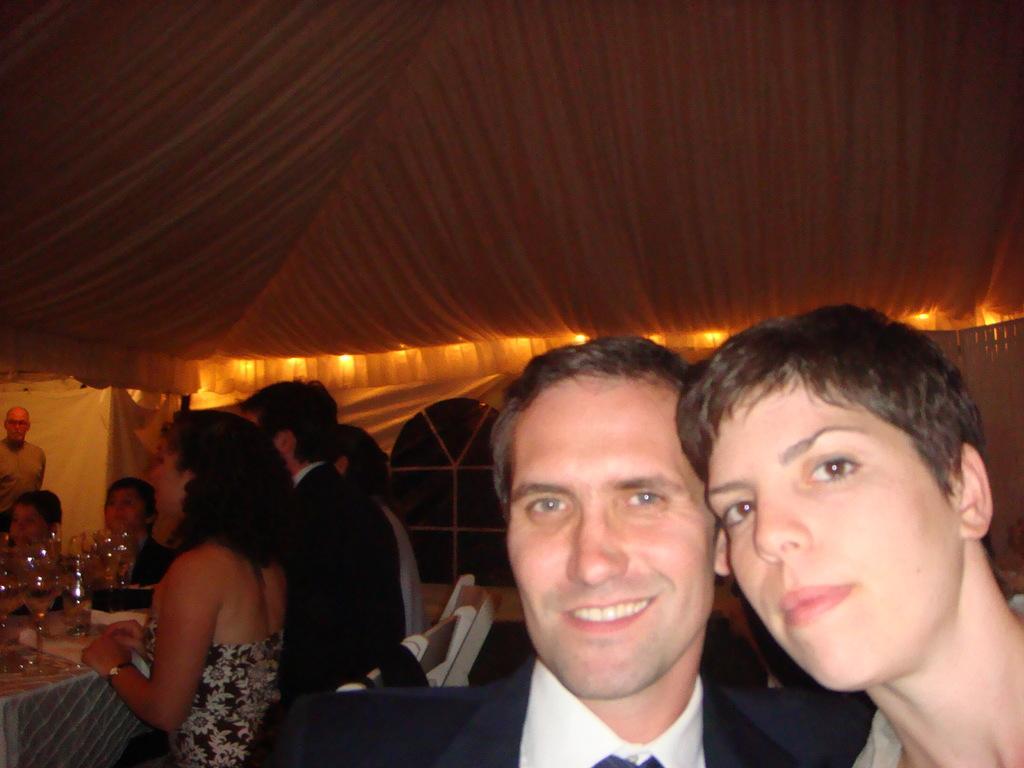Please provide a concise description of this image. In this image we can see two persons on the left side. On the right side there are few people. There is a table. On the table there are glasses. In the back there are lights. Also there is a window. At the top we can see cloth. 